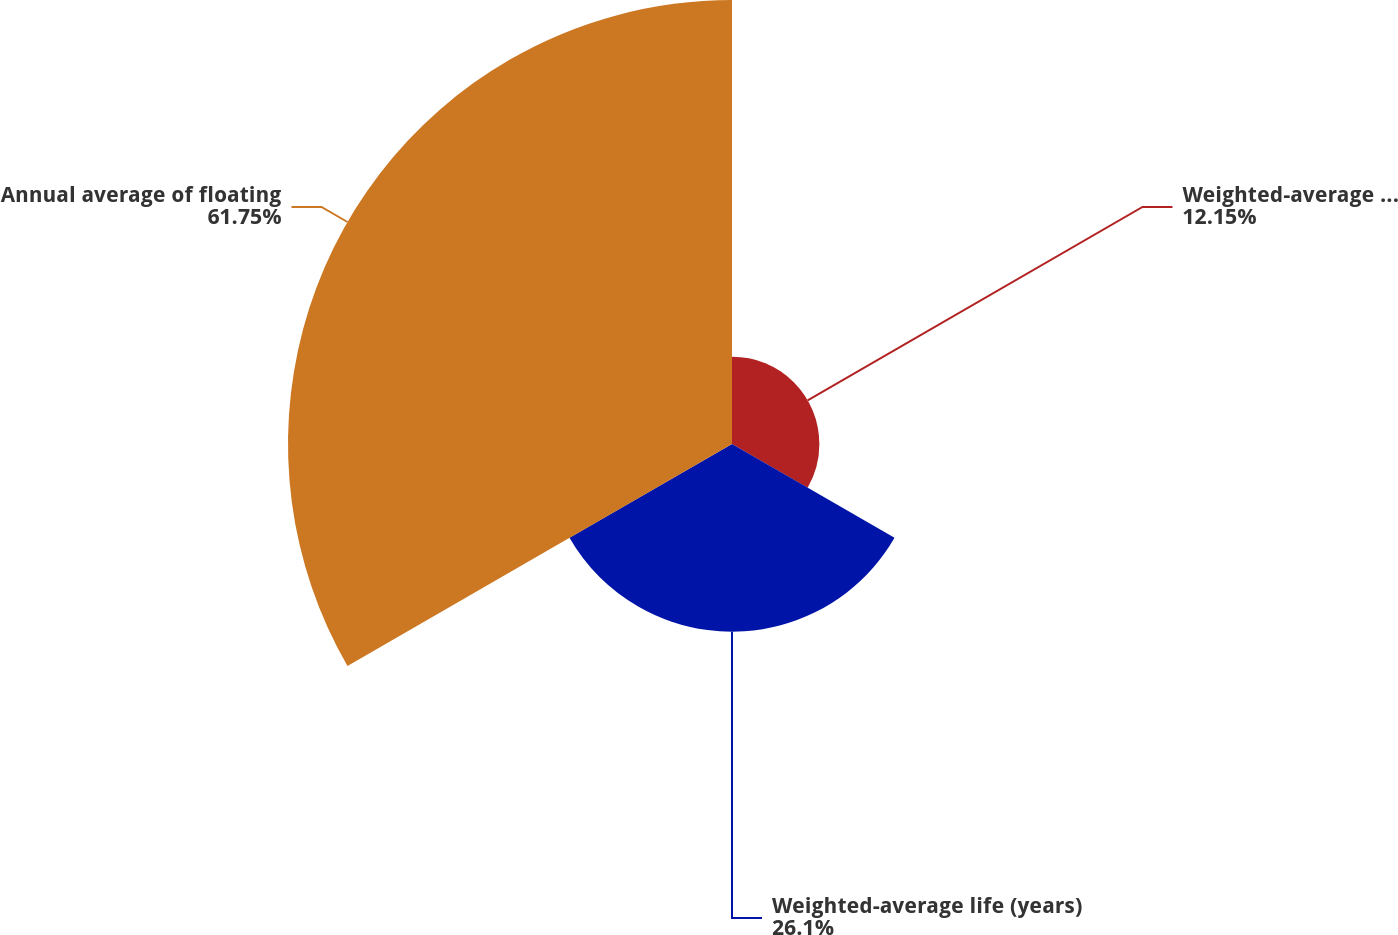<chart> <loc_0><loc_0><loc_500><loc_500><pie_chart><fcel>Weighted-average annual<fcel>Weighted-average life (years)<fcel>Annual average of floating<nl><fcel>12.15%<fcel>26.1%<fcel>61.75%<nl></chart> 